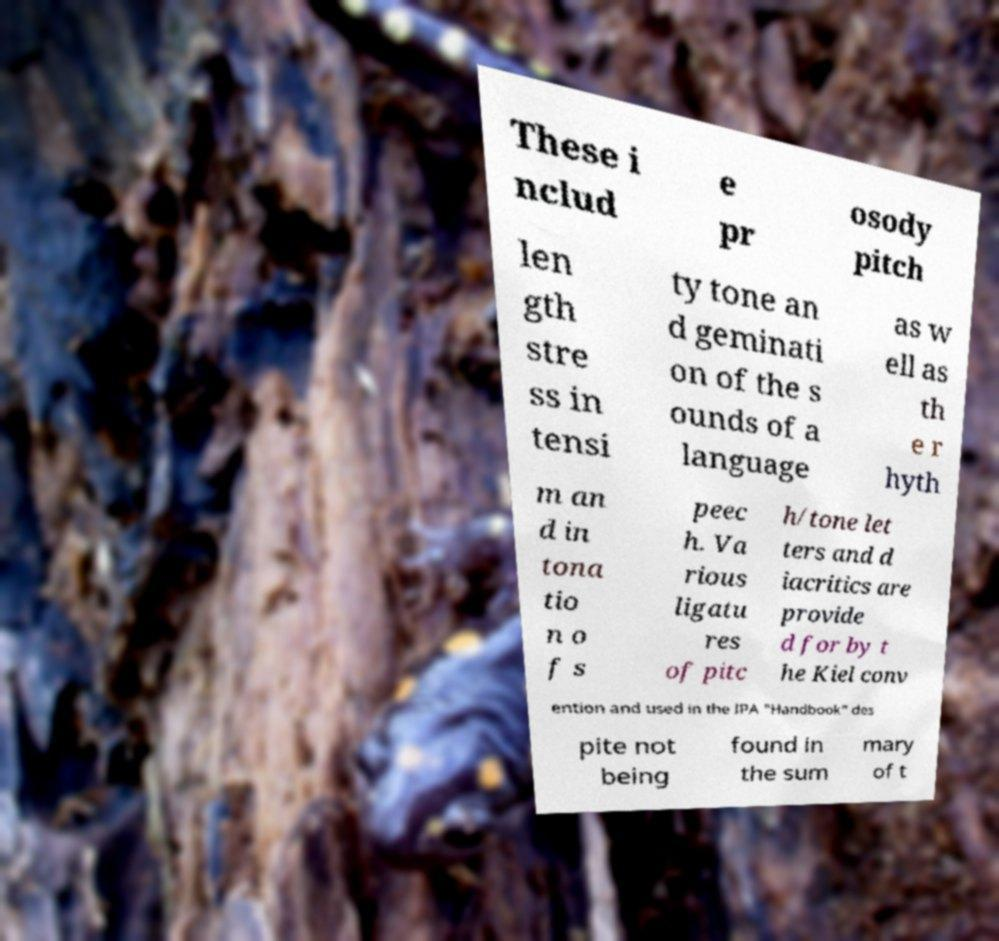There's text embedded in this image that I need extracted. Can you transcribe it verbatim? These i nclud e pr osody pitch len gth stre ss in tensi ty tone an d geminati on of the s ounds of a language as w ell as th e r hyth m an d in tona tio n o f s peec h. Va rious ligatu res of pitc h/tone let ters and d iacritics are provide d for by t he Kiel conv ention and used in the IPA "Handbook" des pite not being found in the sum mary of t 